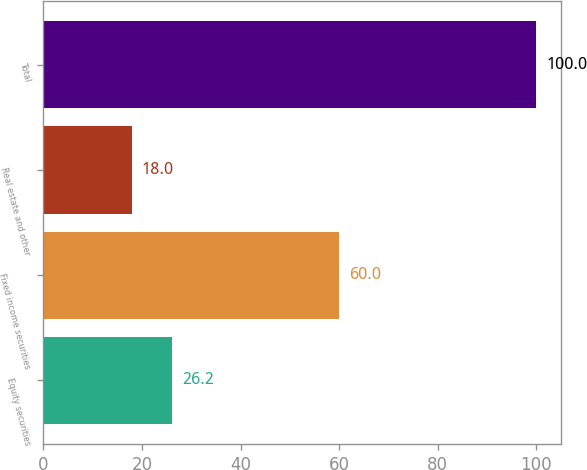<chart> <loc_0><loc_0><loc_500><loc_500><bar_chart><fcel>Equity securities<fcel>Fixed income securities<fcel>Real estate and other<fcel>Total<nl><fcel>26.2<fcel>60<fcel>18<fcel>100<nl></chart> 